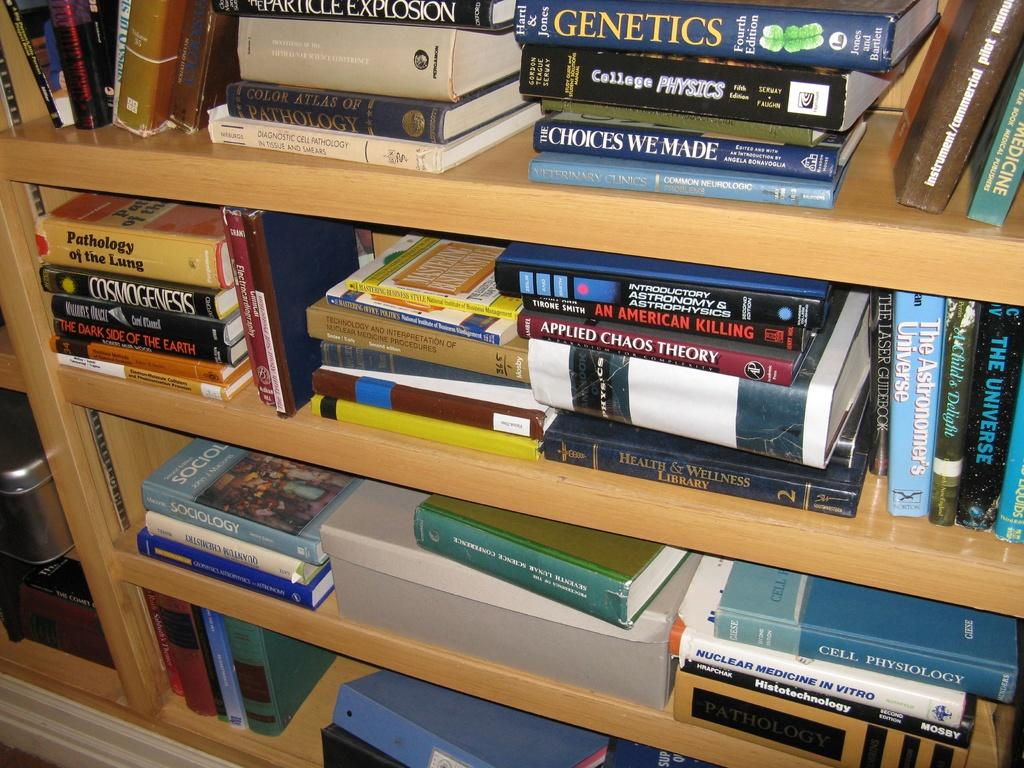<image>
Give a short and clear explanation of the subsequent image. Stack of books on a shelf with one saying Applied Chaos Theory. 